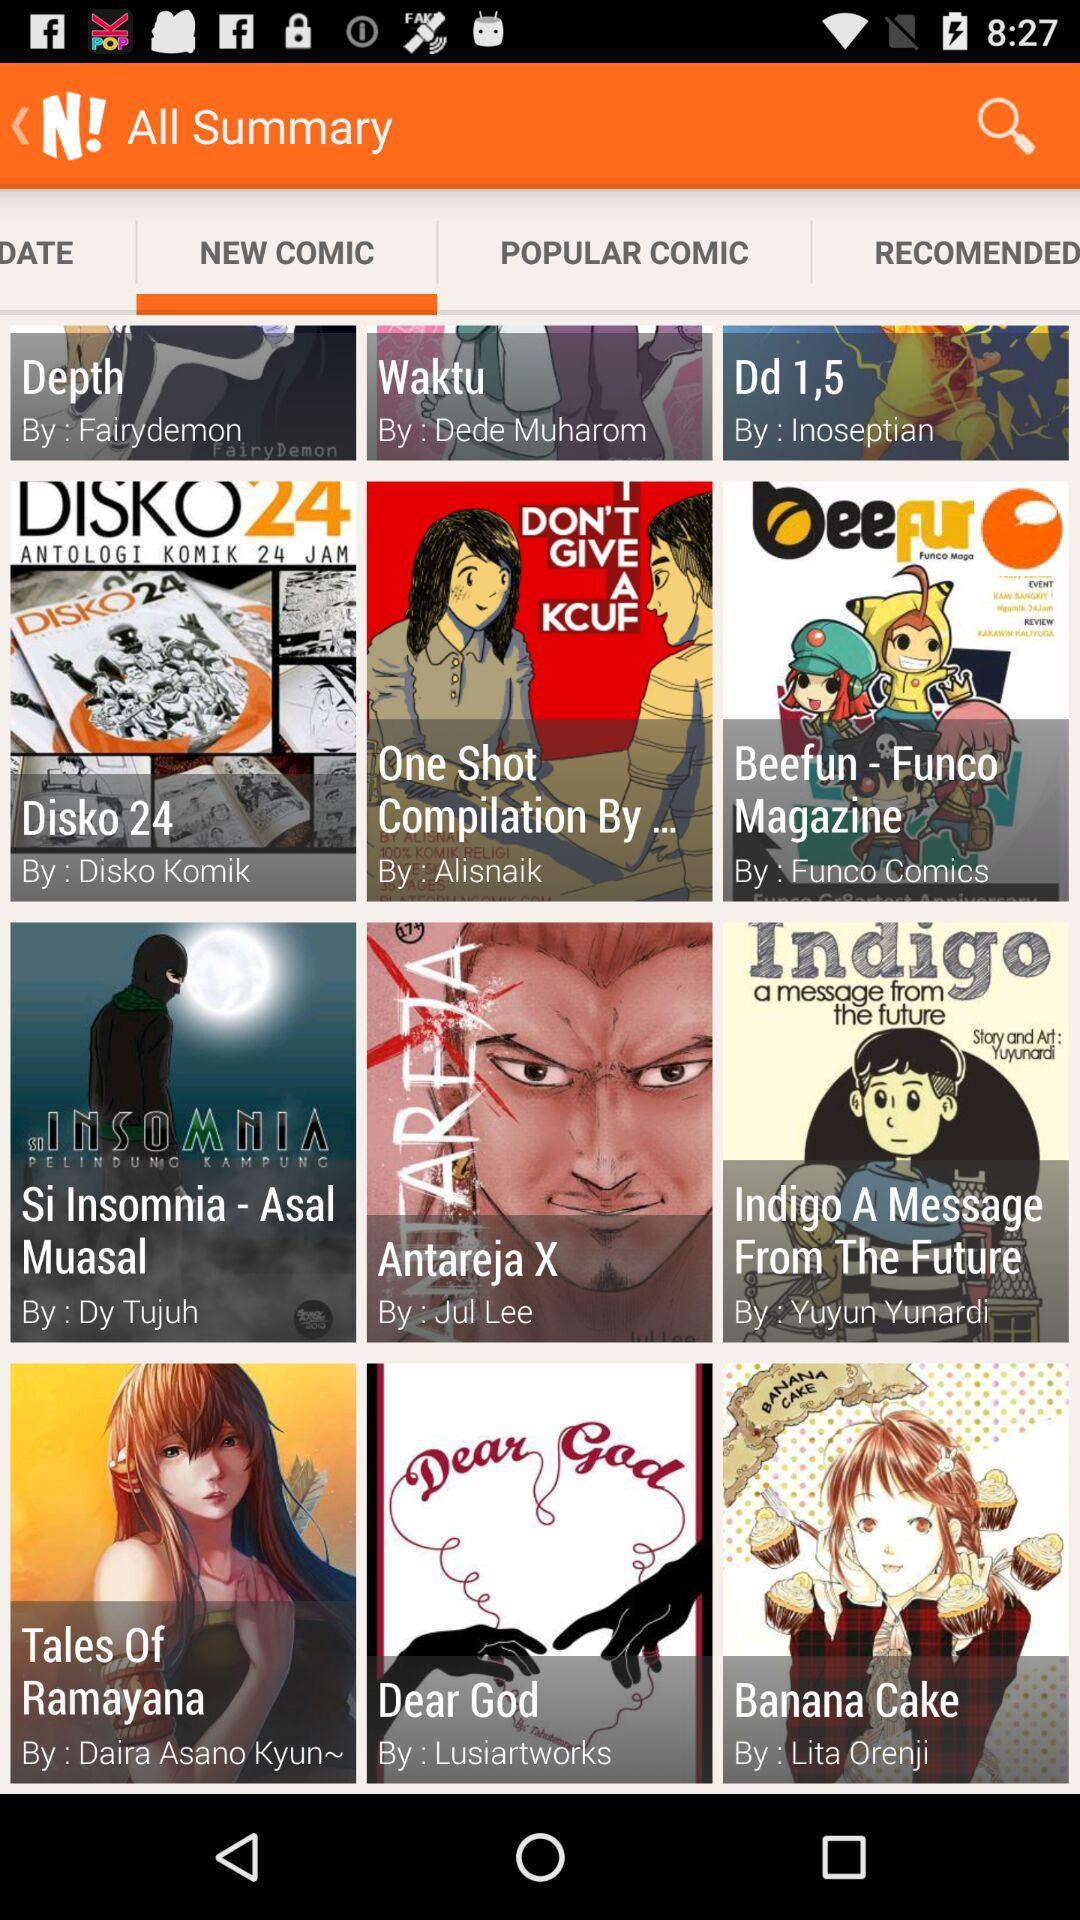Which is the selected tab? The selected tab is "NEW COMIC". 